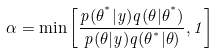<formula> <loc_0><loc_0><loc_500><loc_500>\alpha = \min \left [ \frac { p ( \theta ^ { ^ { * } } | y ) q ( \theta | \theta ^ { ^ { * } } ) } { p ( \theta | y ) q ( \theta ^ { ^ { * } } | \theta ) } , 1 \right ]</formula> 